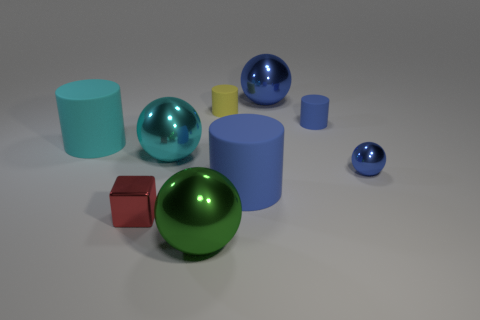Is there anything else that has the same shape as the tiny red object?
Your answer should be compact. No. Is there a tiny yellow cylinder that is right of the small blue object behind the cyan shiny ball?
Offer a terse response. No. There is another large matte object that is the same shape as the large blue rubber thing; what color is it?
Offer a terse response. Cyan. How many objects are the same color as the small sphere?
Offer a terse response. 3. There is a small object left of the large cyan thing that is on the right side of the small object that is in front of the tiny blue metal sphere; what color is it?
Keep it short and to the point. Red. Do the large blue cylinder and the cyan cylinder have the same material?
Offer a very short reply. Yes. Do the large blue shiny object and the small yellow thing have the same shape?
Give a very brief answer. No. Are there an equal number of blue objects that are on the left side of the large green metallic sphere and yellow rubber cylinders that are behind the yellow cylinder?
Your answer should be compact. Yes. There is a tiny cylinder that is the same material as the yellow object; what color is it?
Keep it short and to the point. Blue. How many spheres are the same material as the tiny yellow cylinder?
Provide a short and direct response. 0. 